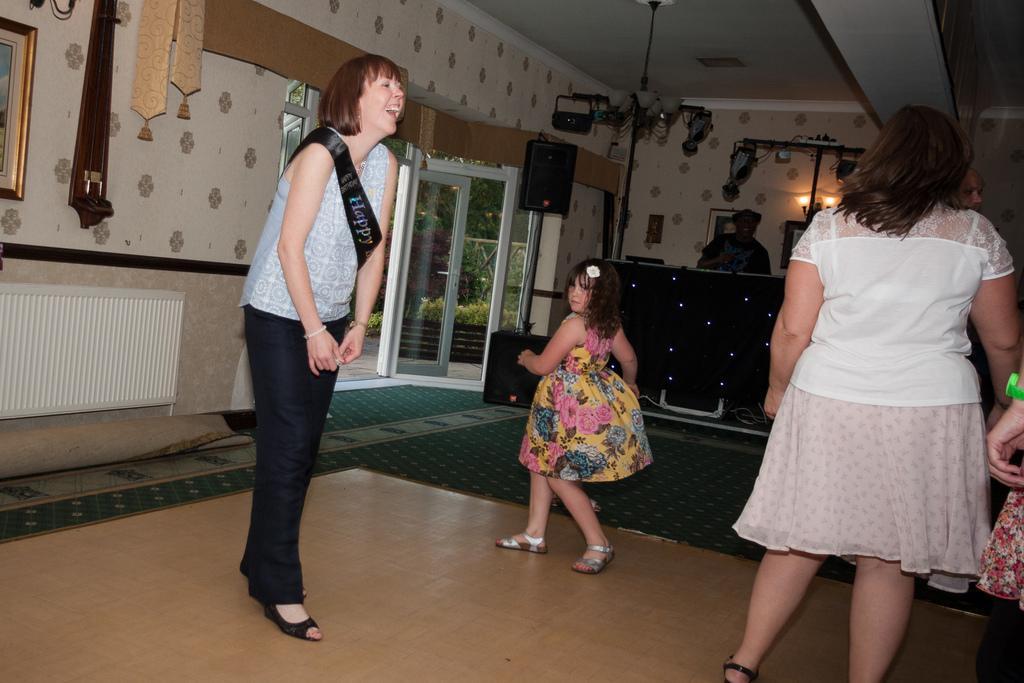Can you describe this image briefly? In this image I can see three persons standing. The person in front wearing frock which is in pink, yellow and green color, background I can see the other person standing, few lights, glass door and trees in green color. I can also see wall in cream color. 